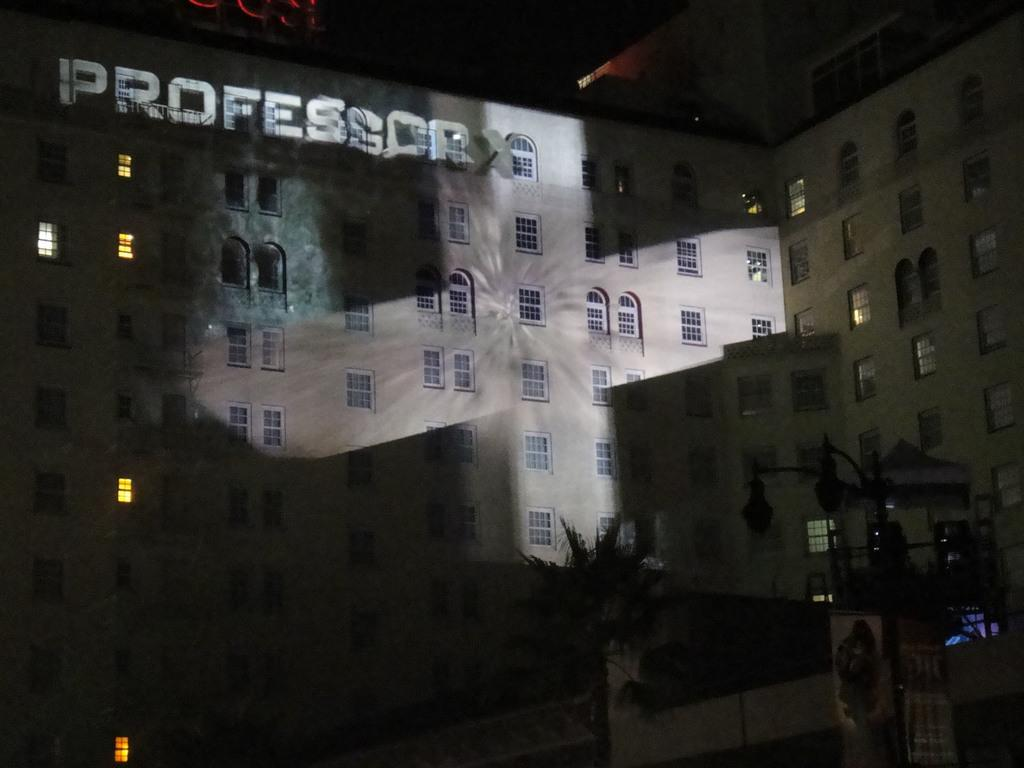What type of structures can be seen in the image? There are buildings in the image. What natural element is present in the image? There is a tree in the image. What type of lighting is visible in the image? There are lights on a pole in the image. What can be found on the wall of a building in the image? There is text on the wall of a building in the image. Reasoning: Let' Let's think step by step in order to produce the conversation. We start by identifying the main subjects in the image, which are the buildings. Then, we expand the conversation to include other elements that are also visible, such as the tree, lights on a pole, and text on a building wall. Each question is designed to elicit a specific detail about the image that is known from the provided facts. Absurd Question/Answer: How many bikes are parked under the tree in the image? There are no bikes present in the image. What type of fruit is hanging from the tree in the image? There is no fruit, including cherries, visible on the tree in the image. How many sheep are grazing near the tree in the image? There are no sheep present in the image. What type of animal is sitting on the wall of the building in the image? There are no animals, including sheep, visible on the wall of the building in the image. 